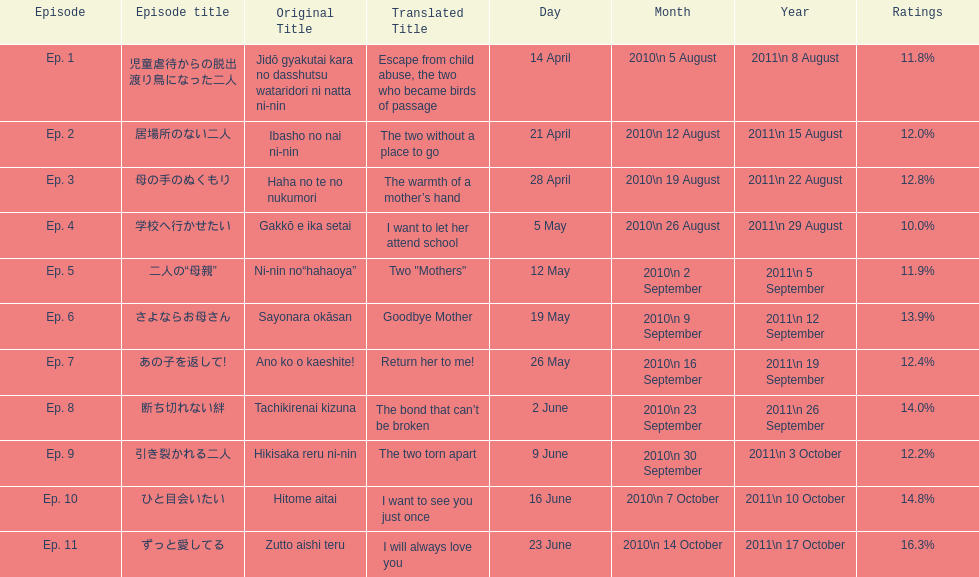How many episodes are listed? 11. 